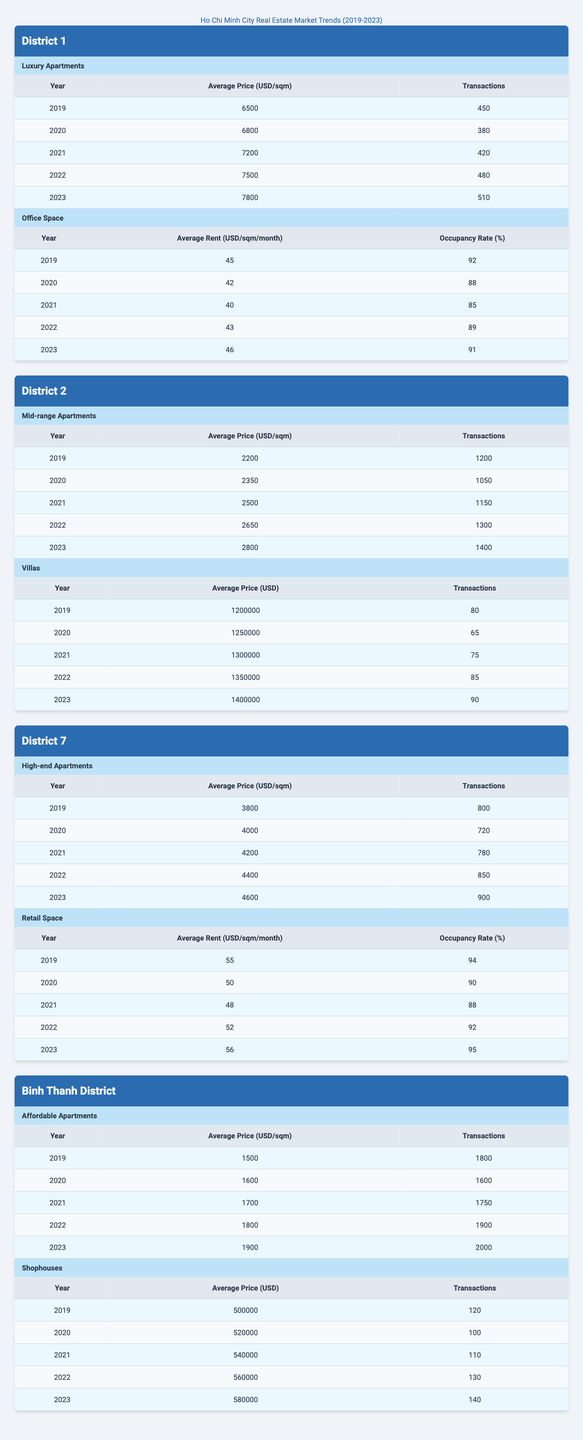What was the highest average price for luxury apartments in District 1? The data shows that the average price for luxury apartments in District 1 reached its peak in 2023 at 7800 USD/sqm.
Answer: 7800 USD/sqm How many transactions of mid-range apartments were recorded in District 2 in 2020? In 2020, there were 1050 transactions recorded for mid-range apartments in District 2, as indicated in the table.
Answer: 1050 What is the trend in average prices of high-end apartments in District 7 from 2019 to 2023? The average price of high-end apartments in District 7 has shown an upward trend, increasing from 3800 USD/sqm in 2019 to 4600 USD/sqm in 2023.
Answer: Increasing What was the average price of affordable apartments in Binh Thanh District in 2021? The average price of affordable apartments in Binh Thanh District in 2021 was 1700 USD/sqm, according to the table.
Answer: 1700 USD/sqm Which type of property in District 2 had the highest number of transactions in 2023? In 2023, mid-range apartments in District 2 had the highest number of transactions at 1400, compared to 90 transactions for villas.
Answer: Mid-range apartments What is the average annual growth rate of average prices for luxury apartments in District 1 from 2019 to 2023? The average price increased from 6500 USD/sqm to 7800 USD/sqm over four years, which calculates to a growth of (7800 - 6500) / 6500 / 4 * 100 = 5.77% per year.
Answer: 5.77% Was the occupancy rate for office space in District 1 higher in 2021 or 2022? In 2021, the occupancy rate was 85%, while in 2022 it increased to 89%, indicating that the occupancy rate was higher in 2022.
Answer: Yes, it was higher in 2022 What was the total number of transactions for shophouses in Binh Thanh District from 2019 to 2023? To find the total transactions for shophouses, add the annual transactions: 120 + 100 + 110 + 130 + 140 = 600.
Answer: 600 In which district was the average rent for retail space in 2023 higher than the average rent in District 1? The average rent for retail space in District 7 in 2023 was 56 USD/sqm/month, which is higher than the 46 USD/sqm/month in District 1.
Answer: District 7 What was the change in average price for villas in District 2 from 2019 to 2023? The average price for villas increased from 1200000 USD in 2019 to 1400000 USD in 2023, resulting in a change of 1400000 - 1200000 = 200000 USD.
Answer: 200000 USD 